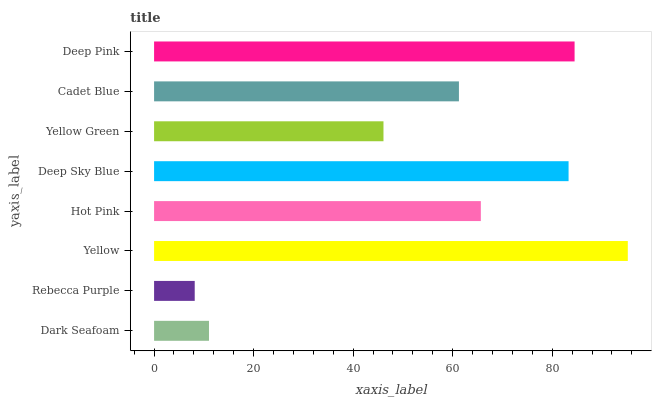Is Rebecca Purple the minimum?
Answer yes or no. Yes. Is Yellow the maximum?
Answer yes or no. Yes. Is Yellow the minimum?
Answer yes or no. No. Is Rebecca Purple the maximum?
Answer yes or no. No. Is Yellow greater than Rebecca Purple?
Answer yes or no. Yes. Is Rebecca Purple less than Yellow?
Answer yes or no. Yes. Is Rebecca Purple greater than Yellow?
Answer yes or no. No. Is Yellow less than Rebecca Purple?
Answer yes or no. No. Is Hot Pink the high median?
Answer yes or no. Yes. Is Cadet Blue the low median?
Answer yes or no. Yes. Is Cadet Blue the high median?
Answer yes or no. No. Is Yellow Green the low median?
Answer yes or no. No. 